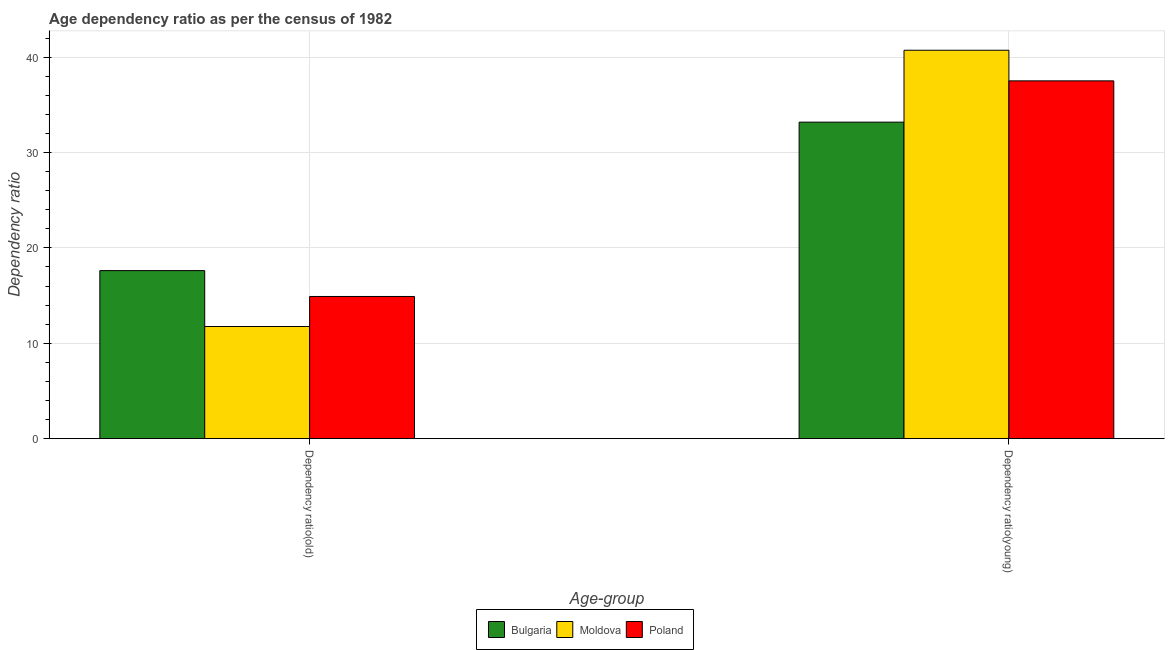How many different coloured bars are there?
Offer a terse response. 3. Are the number of bars per tick equal to the number of legend labels?
Offer a terse response. Yes. How many bars are there on the 1st tick from the left?
Provide a succinct answer. 3. What is the label of the 1st group of bars from the left?
Keep it short and to the point. Dependency ratio(old). What is the age dependency ratio(young) in Bulgaria?
Your answer should be compact. 33.19. Across all countries, what is the maximum age dependency ratio(old)?
Your answer should be very brief. 17.62. Across all countries, what is the minimum age dependency ratio(old)?
Your answer should be very brief. 11.76. In which country was the age dependency ratio(old) minimum?
Offer a terse response. Moldova. What is the total age dependency ratio(old) in the graph?
Your answer should be very brief. 44.29. What is the difference between the age dependency ratio(old) in Bulgaria and that in Poland?
Your answer should be very brief. 2.71. What is the difference between the age dependency ratio(young) in Poland and the age dependency ratio(old) in Moldova?
Offer a very short reply. 25.77. What is the average age dependency ratio(old) per country?
Your answer should be very brief. 14.76. What is the difference between the age dependency ratio(old) and age dependency ratio(young) in Bulgaria?
Make the answer very short. -15.57. What is the ratio of the age dependency ratio(old) in Moldova to that in Poland?
Give a very brief answer. 0.79. What does the 1st bar from the right in Dependency ratio(old) represents?
Your response must be concise. Poland. Are all the bars in the graph horizontal?
Provide a succinct answer. No. How many countries are there in the graph?
Your response must be concise. 3. What is the difference between two consecutive major ticks on the Y-axis?
Offer a very short reply. 10. Does the graph contain grids?
Ensure brevity in your answer.  Yes. How are the legend labels stacked?
Make the answer very short. Horizontal. What is the title of the graph?
Your answer should be very brief. Age dependency ratio as per the census of 1982. Does "Namibia" appear as one of the legend labels in the graph?
Give a very brief answer. No. What is the label or title of the X-axis?
Your response must be concise. Age-group. What is the label or title of the Y-axis?
Keep it short and to the point. Dependency ratio. What is the Dependency ratio of Bulgaria in Dependency ratio(old)?
Give a very brief answer. 17.62. What is the Dependency ratio of Moldova in Dependency ratio(old)?
Offer a terse response. 11.76. What is the Dependency ratio of Poland in Dependency ratio(old)?
Your response must be concise. 14.91. What is the Dependency ratio in Bulgaria in Dependency ratio(young)?
Your response must be concise. 33.19. What is the Dependency ratio of Moldova in Dependency ratio(young)?
Your answer should be compact. 40.73. What is the Dependency ratio in Poland in Dependency ratio(young)?
Your answer should be very brief. 37.52. Across all Age-group, what is the maximum Dependency ratio of Bulgaria?
Your response must be concise. 33.19. Across all Age-group, what is the maximum Dependency ratio of Moldova?
Offer a terse response. 40.73. Across all Age-group, what is the maximum Dependency ratio in Poland?
Provide a succinct answer. 37.52. Across all Age-group, what is the minimum Dependency ratio of Bulgaria?
Ensure brevity in your answer.  17.62. Across all Age-group, what is the minimum Dependency ratio in Moldova?
Provide a succinct answer. 11.76. Across all Age-group, what is the minimum Dependency ratio in Poland?
Your response must be concise. 14.91. What is the total Dependency ratio in Bulgaria in the graph?
Give a very brief answer. 50.81. What is the total Dependency ratio of Moldova in the graph?
Offer a terse response. 52.49. What is the total Dependency ratio in Poland in the graph?
Ensure brevity in your answer.  52.43. What is the difference between the Dependency ratio of Bulgaria in Dependency ratio(old) and that in Dependency ratio(young)?
Provide a short and direct response. -15.57. What is the difference between the Dependency ratio in Moldova in Dependency ratio(old) and that in Dependency ratio(young)?
Your response must be concise. -28.98. What is the difference between the Dependency ratio in Poland in Dependency ratio(old) and that in Dependency ratio(young)?
Your answer should be very brief. -22.61. What is the difference between the Dependency ratio of Bulgaria in Dependency ratio(old) and the Dependency ratio of Moldova in Dependency ratio(young)?
Offer a terse response. -23.11. What is the difference between the Dependency ratio of Bulgaria in Dependency ratio(old) and the Dependency ratio of Poland in Dependency ratio(young)?
Provide a short and direct response. -19.9. What is the difference between the Dependency ratio in Moldova in Dependency ratio(old) and the Dependency ratio in Poland in Dependency ratio(young)?
Make the answer very short. -25.77. What is the average Dependency ratio of Bulgaria per Age-group?
Offer a terse response. 25.41. What is the average Dependency ratio in Moldova per Age-group?
Provide a short and direct response. 26.25. What is the average Dependency ratio of Poland per Age-group?
Your answer should be very brief. 26.22. What is the difference between the Dependency ratio of Bulgaria and Dependency ratio of Moldova in Dependency ratio(old)?
Make the answer very short. 5.86. What is the difference between the Dependency ratio in Bulgaria and Dependency ratio in Poland in Dependency ratio(old)?
Give a very brief answer. 2.71. What is the difference between the Dependency ratio in Moldova and Dependency ratio in Poland in Dependency ratio(old)?
Keep it short and to the point. -3.15. What is the difference between the Dependency ratio in Bulgaria and Dependency ratio in Moldova in Dependency ratio(young)?
Your answer should be compact. -7.54. What is the difference between the Dependency ratio in Bulgaria and Dependency ratio in Poland in Dependency ratio(young)?
Offer a terse response. -4.33. What is the difference between the Dependency ratio of Moldova and Dependency ratio of Poland in Dependency ratio(young)?
Your answer should be very brief. 3.21. What is the ratio of the Dependency ratio in Bulgaria in Dependency ratio(old) to that in Dependency ratio(young)?
Offer a terse response. 0.53. What is the ratio of the Dependency ratio in Moldova in Dependency ratio(old) to that in Dependency ratio(young)?
Keep it short and to the point. 0.29. What is the ratio of the Dependency ratio of Poland in Dependency ratio(old) to that in Dependency ratio(young)?
Provide a short and direct response. 0.4. What is the difference between the highest and the second highest Dependency ratio of Bulgaria?
Give a very brief answer. 15.57. What is the difference between the highest and the second highest Dependency ratio of Moldova?
Your answer should be compact. 28.98. What is the difference between the highest and the second highest Dependency ratio of Poland?
Make the answer very short. 22.61. What is the difference between the highest and the lowest Dependency ratio of Bulgaria?
Give a very brief answer. 15.57. What is the difference between the highest and the lowest Dependency ratio in Moldova?
Offer a very short reply. 28.98. What is the difference between the highest and the lowest Dependency ratio of Poland?
Your response must be concise. 22.61. 